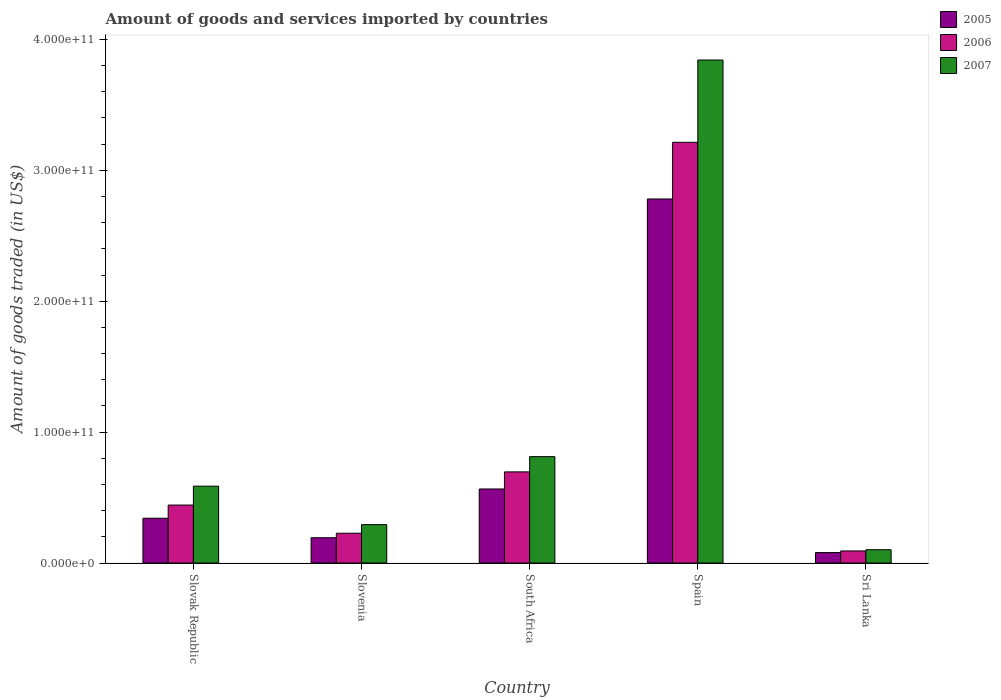Are the number of bars on each tick of the X-axis equal?
Offer a very short reply. Yes. How many bars are there on the 5th tick from the left?
Your answer should be compact. 3. What is the label of the 3rd group of bars from the left?
Your response must be concise. South Africa. What is the total amount of goods and services imported in 2007 in South Africa?
Provide a short and direct response. 8.13e+1. Across all countries, what is the maximum total amount of goods and services imported in 2006?
Your answer should be very brief. 3.21e+11. Across all countries, what is the minimum total amount of goods and services imported in 2007?
Keep it short and to the point. 1.02e+1. In which country was the total amount of goods and services imported in 2005 minimum?
Provide a succinct answer. Sri Lanka. What is the total total amount of goods and services imported in 2005 in the graph?
Provide a short and direct response. 3.96e+11. What is the difference between the total amount of goods and services imported in 2007 in Slovenia and that in Sri Lanka?
Provide a short and direct response. 1.92e+1. What is the difference between the total amount of goods and services imported in 2005 in Sri Lanka and the total amount of goods and services imported in 2006 in Slovak Republic?
Keep it short and to the point. -3.63e+1. What is the average total amount of goods and services imported in 2006 per country?
Keep it short and to the point. 9.35e+1. What is the difference between the total amount of goods and services imported of/in 2007 and total amount of goods and services imported of/in 2006 in Sri Lanka?
Your answer should be compact. 9.39e+08. What is the ratio of the total amount of goods and services imported in 2006 in Slovak Republic to that in South Africa?
Your response must be concise. 0.64. Is the total amount of goods and services imported in 2006 in Slovenia less than that in South Africa?
Your response must be concise. Yes. Is the difference between the total amount of goods and services imported in 2007 in Slovak Republic and Spain greater than the difference between the total amount of goods and services imported in 2006 in Slovak Republic and Spain?
Your response must be concise. No. What is the difference between the highest and the second highest total amount of goods and services imported in 2006?
Ensure brevity in your answer.  2.77e+11. What is the difference between the highest and the lowest total amount of goods and services imported in 2007?
Your response must be concise. 3.74e+11. Is the sum of the total amount of goods and services imported in 2005 in Slovenia and Sri Lanka greater than the maximum total amount of goods and services imported in 2006 across all countries?
Your answer should be very brief. No. What does the 1st bar from the right in Spain represents?
Keep it short and to the point. 2007. Is it the case that in every country, the sum of the total amount of goods and services imported in 2006 and total amount of goods and services imported in 2007 is greater than the total amount of goods and services imported in 2005?
Provide a short and direct response. Yes. How many countries are there in the graph?
Your answer should be compact. 5. What is the difference between two consecutive major ticks on the Y-axis?
Provide a succinct answer. 1.00e+11. Does the graph contain any zero values?
Ensure brevity in your answer.  No. Does the graph contain grids?
Provide a succinct answer. No. How many legend labels are there?
Provide a succinct answer. 3. How are the legend labels stacked?
Provide a short and direct response. Vertical. What is the title of the graph?
Make the answer very short. Amount of goods and services imported by countries. What is the label or title of the Y-axis?
Your answer should be compact. Amount of goods traded (in US$). What is the Amount of goods traded (in US$) in 2005 in Slovak Republic?
Make the answer very short. 3.42e+1. What is the Amount of goods traded (in US$) in 2006 in Slovak Republic?
Provide a succinct answer. 4.43e+1. What is the Amount of goods traded (in US$) in 2007 in Slovak Republic?
Give a very brief answer. 5.87e+1. What is the Amount of goods traded (in US$) of 2005 in Slovenia?
Ensure brevity in your answer.  1.93e+1. What is the Amount of goods traded (in US$) in 2006 in Slovenia?
Your response must be concise. 2.28e+1. What is the Amount of goods traded (in US$) of 2007 in Slovenia?
Your answer should be very brief. 2.93e+1. What is the Amount of goods traded (in US$) of 2005 in South Africa?
Keep it short and to the point. 5.66e+1. What is the Amount of goods traded (in US$) of 2006 in South Africa?
Your answer should be compact. 6.96e+1. What is the Amount of goods traded (in US$) of 2007 in South Africa?
Ensure brevity in your answer.  8.13e+1. What is the Amount of goods traded (in US$) in 2005 in Spain?
Provide a succinct answer. 2.78e+11. What is the Amount of goods traded (in US$) of 2006 in Spain?
Ensure brevity in your answer.  3.21e+11. What is the Amount of goods traded (in US$) in 2007 in Spain?
Offer a terse response. 3.84e+11. What is the Amount of goods traded (in US$) of 2005 in Sri Lanka?
Give a very brief answer. 7.98e+09. What is the Amount of goods traded (in US$) of 2006 in Sri Lanka?
Make the answer very short. 9.23e+09. What is the Amount of goods traded (in US$) of 2007 in Sri Lanka?
Offer a very short reply. 1.02e+1. Across all countries, what is the maximum Amount of goods traded (in US$) in 2005?
Your response must be concise. 2.78e+11. Across all countries, what is the maximum Amount of goods traded (in US$) in 2006?
Keep it short and to the point. 3.21e+11. Across all countries, what is the maximum Amount of goods traded (in US$) of 2007?
Keep it short and to the point. 3.84e+11. Across all countries, what is the minimum Amount of goods traded (in US$) of 2005?
Provide a succinct answer. 7.98e+09. Across all countries, what is the minimum Amount of goods traded (in US$) in 2006?
Your answer should be compact. 9.23e+09. Across all countries, what is the minimum Amount of goods traded (in US$) in 2007?
Your answer should be compact. 1.02e+1. What is the total Amount of goods traded (in US$) in 2005 in the graph?
Your answer should be very brief. 3.96e+11. What is the total Amount of goods traded (in US$) in 2006 in the graph?
Give a very brief answer. 4.67e+11. What is the total Amount of goods traded (in US$) of 2007 in the graph?
Keep it short and to the point. 5.64e+11. What is the difference between the Amount of goods traded (in US$) of 2005 in Slovak Republic and that in Slovenia?
Make the answer very short. 1.49e+1. What is the difference between the Amount of goods traded (in US$) in 2006 in Slovak Republic and that in Slovenia?
Keep it short and to the point. 2.15e+1. What is the difference between the Amount of goods traded (in US$) of 2007 in Slovak Republic and that in Slovenia?
Your answer should be very brief. 2.94e+1. What is the difference between the Amount of goods traded (in US$) in 2005 in Slovak Republic and that in South Africa?
Provide a succinct answer. -2.24e+1. What is the difference between the Amount of goods traded (in US$) in 2006 in Slovak Republic and that in South Africa?
Offer a terse response. -2.53e+1. What is the difference between the Amount of goods traded (in US$) in 2007 in Slovak Republic and that in South Africa?
Your answer should be compact. -2.25e+1. What is the difference between the Amount of goods traded (in US$) in 2005 in Slovak Republic and that in Spain?
Offer a very short reply. -2.44e+11. What is the difference between the Amount of goods traded (in US$) of 2006 in Slovak Republic and that in Spain?
Your answer should be very brief. -2.77e+11. What is the difference between the Amount of goods traded (in US$) in 2007 in Slovak Republic and that in Spain?
Offer a very short reply. -3.26e+11. What is the difference between the Amount of goods traded (in US$) of 2005 in Slovak Republic and that in Sri Lanka?
Provide a succinct answer. 2.62e+1. What is the difference between the Amount of goods traded (in US$) of 2006 in Slovak Republic and that in Sri Lanka?
Give a very brief answer. 3.51e+1. What is the difference between the Amount of goods traded (in US$) of 2007 in Slovak Republic and that in Sri Lanka?
Provide a succinct answer. 4.85e+1. What is the difference between the Amount of goods traded (in US$) in 2005 in Slovenia and that in South Africa?
Make the answer very short. -3.72e+1. What is the difference between the Amount of goods traded (in US$) in 2006 in Slovenia and that in South Africa?
Provide a short and direct response. -4.69e+1. What is the difference between the Amount of goods traded (in US$) of 2007 in Slovenia and that in South Africa?
Offer a very short reply. -5.19e+1. What is the difference between the Amount of goods traded (in US$) in 2005 in Slovenia and that in Spain?
Offer a very short reply. -2.59e+11. What is the difference between the Amount of goods traded (in US$) in 2006 in Slovenia and that in Spain?
Your answer should be compact. -2.99e+11. What is the difference between the Amount of goods traded (in US$) of 2007 in Slovenia and that in Spain?
Provide a short and direct response. -3.55e+11. What is the difference between the Amount of goods traded (in US$) in 2005 in Slovenia and that in Sri Lanka?
Offer a terse response. 1.13e+1. What is the difference between the Amount of goods traded (in US$) of 2006 in Slovenia and that in Sri Lanka?
Give a very brief answer. 1.35e+1. What is the difference between the Amount of goods traded (in US$) of 2007 in Slovenia and that in Sri Lanka?
Ensure brevity in your answer.  1.92e+1. What is the difference between the Amount of goods traded (in US$) of 2005 in South Africa and that in Spain?
Provide a succinct answer. -2.22e+11. What is the difference between the Amount of goods traded (in US$) in 2006 in South Africa and that in Spain?
Offer a very short reply. -2.52e+11. What is the difference between the Amount of goods traded (in US$) in 2007 in South Africa and that in Spain?
Give a very brief answer. -3.03e+11. What is the difference between the Amount of goods traded (in US$) of 2005 in South Africa and that in Sri Lanka?
Offer a very short reply. 4.86e+1. What is the difference between the Amount of goods traded (in US$) in 2006 in South Africa and that in Sri Lanka?
Give a very brief answer. 6.04e+1. What is the difference between the Amount of goods traded (in US$) in 2007 in South Africa and that in Sri Lanka?
Keep it short and to the point. 7.11e+1. What is the difference between the Amount of goods traded (in US$) in 2005 in Spain and that in Sri Lanka?
Your answer should be compact. 2.70e+11. What is the difference between the Amount of goods traded (in US$) of 2006 in Spain and that in Sri Lanka?
Provide a succinct answer. 3.12e+11. What is the difference between the Amount of goods traded (in US$) of 2007 in Spain and that in Sri Lanka?
Make the answer very short. 3.74e+11. What is the difference between the Amount of goods traded (in US$) of 2005 in Slovak Republic and the Amount of goods traded (in US$) of 2006 in Slovenia?
Your answer should be very brief. 1.14e+1. What is the difference between the Amount of goods traded (in US$) of 2005 in Slovak Republic and the Amount of goods traded (in US$) of 2007 in Slovenia?
Your answer should be very brief. 4.88e+09. What is the difference between the Amount of goods traded (in US$) of 2006 in Slovak Republic and the Amount of goods traded (in US$) of 2007 in Slovenia?
Ensure brevity in your answer.  1.50e+1. What is the difference between the Amount of goods traded (in US$) in 2005 in Slovak Republic and the Amount of goods traded (in US$) in 2006 in South Africa?
Ensure brevity in your answer.  -3.54e+1. What is the difference between the Amount of goods traded (in US$) in 2005 in Slovak Republic and the Amount of goods traded (in US$) in 2007 in South Africa?
Your answer should be very brief. -4.70e+1. What is the difference between the Amount of goods traded (in US$) of 2006 in Slovak Republic and the Amount of goods traded (in US$) of 2007 in South Africa?
Your answer should be compact. -3.70e+1. What is the difference between the Amount of goods traded (in US$) in 2005 in Slovak Republic and the Amount of goods traded (in US$) in 2006 in Spain?
Keep it short and to the point. -2.87e+11. What is the difference between the Amount of goods traded (in US$) of 2005 in Slovak Republic and the Amount of goods traded (in US$) of 2007 in Spain?
Ensure brevity in your answer.  -3.50e+11. What is the difference between the Amount of goods traded (in US$) in 2006 in Slovak Republic and the Amount of goods traded (in US$) in 2007 in Spain?
Provide a succinct answer. -3.40e+11. What is the difference between the Amount of goods traded (in US$) of 2005 in Slovak Republic and the Amount of goods traded (in US$) of 2006 in Sri Lanka?
Provide a short and direct response. 2.50e+1. What is the difference between the Amount of goods traded (in US$) in 2005 in Slovak Republic and the Amount of goods traded (in US$) in 2007 in Sri Lanka?
Ensure brevity in your answer.  2.40e+1. What is the difference between the Amount of goods traded (in US$) of 2006 in Slovak Republic and the Amount of goods traded (in US$) of 2007 in Sri Lanka?
Provide a short and direct response. 3.41e+1. What is the difference between the Amount of goods traded (in US$) of 2005 in Slovenia and the Amount of goods traded (in US$) of 2006 in South Africa?
Provide a succinct answer. -5.03e+1. What is the difference between the Amount of goods traded (in US$) in 2005 in Slovenia and the Amount of goods traded (in US$) in 2007 in South Africa?
Offer a terse response. -6.19e+1. What is the difference between the Amount of goods traded (in US$) of 2006 in Slovenia and the Amount of goods traded (in US$) of 2007 in South Africa?
Give a very brief answer. -5.85e+1. What is the difference between the Amount of goods traded (in US$) of 2005 in Slovenia and the Amount of goods traded (in US$) of 2006 in Spain?
Your response must be concise. -3.02e+11. What is the difference between the Amount of goods traded (in US$) of 2005 in Slovenia and the Amount of goods traded (in US$) of 2007 in Spain?
Give a very brief answer. -3.65e+11. What is the difference between the Amount of goods traded (in US$) in 2006 in Slovenia and the Amount of goods traded (in US$) in 2007 in Spain?
Offer a terse response. -3.61e+11. What is the difference between the Amount of goods traded (in US$) of 2005 in Slovenia and the Amount of goods traded (in US$) of 2006 in Sri Lanka?
Your response must be concise. 1.01e+1. What is the difference between the Amount of goods traded (in US$) in 2005 in Slovenia and the Amount of goods traded (in US$) in 2007 in Sri Lanka?
Give a very brief answer. 9.16e+09. What is the difference between the Amount of goods traded (in US$) in 2006 in Slovenia and the Amount of goods traded (in US$) in 2007 in Sri Lanka?
Your answer should be very brief. 1.26e+1. What is the difference between the Amount of goods traded (in US$) in 2005 in South Africa and the Amount of goods traded (in US$) in 2006 in Spain?
Your answer should be very brief. -2.65e+11. What is the difference between the Amount of goods traded (in US$) of 2005 in South Africa and the Amount of goods traded (in US$) of 2007 in Spain?
Offer a very short reply. -3.28e+11. What is the difference between the Amount of goods traded (in US$) of 2006 in South Africa and the Amount of goods traded (in US$) of 2007 in Spain?
Your response must be concise. -3.15e+11. What is the difference between the Amount of goods traded (in US$) in 2005 in South Africa and the Amount of goods traded (in US$) in 2006 in Sri Lanka?
Provide a succinct answer. 4.73e+1. What is the difference between the Amount of goods traded (in US$) in 2005 in South Africa and the Amount of goods traded (in US$) in 2007 in Sri Lanka?
Provide a succinct answer. 4.64e+1. What is the difference between the Amount of goods traded (in US$) in 2006 in South Africa and the Amount of goods traded (in US$) in 2007 in Sri Lanka?
Your answer should be compact. 5.95e+1. What is the difference between the Amount of goods traded (in US$) in 2005 in Spain and the Amount of goods traded (in US$) in 2006 in Sri Lanka?
Ensure brevity in your answer.  2.69e+11. What is the difference between the Amount of goods traded (in US$) of 2005 in Spain and the Amount of goods traded (in US$) of 2007 in Sri Lanka?
Provide a short and direct response. 2.68e+11. What is the difference between the Amount of goods traded (in US$) of 2006 in Spain and the Amount of goods traded (in US$) of 2007 in Sri Lanka?
Make the answer very short. 3.11e+11. What is the average Amount of goods traded (in US$) in 2005 per country?
Provide a succinct answer. 7.92e+1. What is the average Amount of goods traded (in US$) in 2006 per country?
Your answer should be very brief. 9.35e+1. What is the average Amount of goods traded (in US$) in 2007 per country?
Ensure brevity in your answer.  1.13e+11. What is the difference between the Amount of goods traded (in US$) in 2005 and Amount of goods traded (in US$) in 2006 in Slovak Republic?
Provide a short and direct response. -1.01e+1. What is the difference between the Amount of goods traded (in US$) in 2005 and Amount of goods traded (in US$) in 2007 in Slovak Republic?
Your answer should be compact. -2.45e+1. What is the difference between the Amount of goods traded (in US$) in 2006 and Amount of goods traded (in US$) in 2007 in Slovak Republic?
Your response must be concise. -1.44e+1. What is the difference between the Amount of goods traded (in US$) in 2005 and Amount of goods traded (in US$) in 2006 in Slovenia?
Provide a succinct answer. -3.45e+09. What is the difference between the Amount of goods traded (in US$) of 2005 and Amount of goods traded (in US$) of 2007 in Slovenia?
Give a very brief answer. -1.00e+1. What is the difference between the Amount of goods traded (in US$) of 2006 and Amount of goods traded (in US$) of 2007 in Slovenia?
Provide a short and direct response. -6.56e+09. What is the difference between the Amount of goods traded (in US$) of 2005 and Amount of goods traded (in US$) of 2006 in South Africa?
Offer a very short reply. -1.31e+1. What is the difference between the Amount of goods traded (in US$) of 2005 and Amount of goods traded (in US$) of 2007 in South Africa?
Offer a very short reply. -2.47e+1. What is the difference between the Amount of goods traded (in US$) in 2006 and Amount of goods traded (in US$) in 2007 in South Africa?
Offer a terse response. -1.16e+1. What is the difference between the Amount of goods traded (in US$) in 2005 and Amount of goods traded (in US$) in 2006 in Spain?
Keep it short and to the point. -4.33e+1. What is the difference between the Amount of goods traded (in US$) in 2005 and Amount of goods traded (in US$) in 2007 in Spain?
Your answer should be very brief. -1.06e+11. What is the difference between the Amount of goods traded (in US$) in 2006 and Amount of goods traded (in US$) in 2007 in Spain?
Make the answer very short. -6.29e+1. What is the difference between the Amount of goods traded (in US$) of 2005 and Amount of goods traded (in US$) of 2006 in Sri Lanka?
Ensure brevity in your answer.  -1.25e+09. What is the difference between the Amount of goods traded (in US$) of 2005 and Amount of goods traded (in US$) of 2007 in Sri Lanka?
Offer a very short reply. -2.19e+09. What is the difference between the Amount of goods traded (in US$) in 2006 and Amount of goods traded (in US$) in 2007 in Sri Lanka?
Offer a terse response. -9.39e+08. What is the ratio of the Amount of goods traded (in US$) in 2005 in Slovak Republic to that in Slovenia?
Ensure brevity in your answer.  1.77. What is the ratio of the Amount of goods traded (in US$) of 2006 in Slovak Republic to that in Slovenia?
Your answer should be compact. 1.94. What is the ratio of the Amount of goods traded (in US$) in 2007 in Slovak Republic to that in Slovenia?
Provide a short and direct response. 2. What is the ratio of the Amount of goods traded (in US$) of 2005 in Slovak Republic to that in South Africa?
Provide a short and direct response. 0.6. What is the ratio of the Amount of goods traded (in US$) in 2006 in Slovak Republic to that in South Africa?
Ensure brevity in your answer.  0.64. What is the ratio of the Amount of goods traded (in US$) of 2007 in Slovak Republic to that in South Africa?
Give a very brief answer. 0.72. What is the ratio of the Amount of goods traded (in US$) in 2005 in Slovak Republic to that in Spain?
Offer a very short reply. 0.12. What is the ratio of the Amount of goods traded (in US$) in 2006 in Slovak Republic to that in Spain?
Your answer should be very brief. 0.14. What is the ratio of the Amount of goods traded (in US$) in 2007 in Slovak Republic to that in Spain?
Provide a succinct answer. 0.15. What is the ratio of the Amount of goods traded (in US$) in 2005 in Slovak Republic to that in Sri Lanka?
Your answer should be very brief. 4.29. What is the ratio of the Amount of goods traded (in US$) of 2006 in Slovak Republic to that in Sri Lanka?
Give a very brief answer. 4.8. What is the ratio of the Amount of goods traded (in US$) of 2007 in Slovak Republic to that in Sri Lanka?
Offer a terse response. 5.78. What is the ratio of the Amount of goods traded (in US$) in 2005 in Slovenia to that in South Africa?
Your answer should be very brief. 0.34. What is the ratio of the Amount of goods traded (in US$) in 2006 in Slovenia to that in South Africa?
Make the answer very short. 0.33. What is the ratio of the Amount of goods traded (in US$) in 2007 in Slovenia to that in South Africa?
Give a very brief answer. 0.36. What is the ratio of the Amount of goods traded (in US$) in 2005 in Slovenia to that in Spain?
Your answer should be very brief. 0.07. What is the ratio of the Amount of goods traded (in US$) of 2006 in Slovenia to that in Spain?
Your response must be concise. 0.07. What is the ratio of the Amount of goods traded (in US$) of 2007 in Slovenia to that in Spain?
Make the answer very short. 0.08. What is the ratio of the Amount of goods traded (in US$) of 2005 in Slovenia to that in Sri Lanka?
Make the answer very short. 2.42. What is the ratio of the Amount of goods traded (in US$) of 2006 in Slovenia to that in Sri Lanka?
Your answer should be very brief. 2.47. What is the ratio of the Amount of goods traded (in US$) of 2007 in Slovenia to that in Sri Lanka?
Your answer should be compact. 2.88. What is the ratio of the Amount of goods traded (in US$) in 2005 in South Africa to that in Spain?
Give a very brief answer. 0.2. What is the ratio of the Amount of goods traded (in US$) of 2006 in South Africa to that in Spain?
Your answer should be very brief. 0.22. What is the ratio of the Amount of goods traded (in US$) of 2007 in South Africa to that in Spain?
Offer a terse response. 0.21. What is the ratio of the Amount of goods traded (in US$) in 2005 in South Africa to that in Sri Lanka?
Your answer should be compact. 7.09. What is the ratio of the Amount of goods traded (in US$) in 2006 in South Africa to that in Sri Lanka?
Your answer should be compact. 7.55. What is the ratio of the Amount of goods traded (in US$) in 2007 in South Africa to that in Sri Lanka?
Provide a succinct answer. 7.99. What is the ratio of the Amount of goods traded (in US$) in 2005 in Spain to that in Sri Lanka?
Your answer should be very brief. 34.86. What is the ratio of the Amount of goods traded (in US$) in 2006 in Spain to that in Sri Lanka?
Provide a succinct answer. 34.83. What is the ratio of the Amount of goods traded (in US$) of 2007 in Spain to that in Sri Lanka?
Your response must be concise. 37.79. What is the difference between the highest and the second highest Amount of goods traded (in US$) in 2005?
Your answer should be compact. 2.22e+11. What is the difference between the highest and the second highest Amount of goods traded (in US$) of 2006?
Keep it short and to the point. 2.52e+11. What is the difference between the highest and the second highest Amount of goods traded (in US$) of 2007?
Offer a very short reply. 3.03e+11. What is the difference between the highest and the lowest Amount of goods traded (in US$) of 2005?
Ensure brevity in your answer.  2.70e+11. What is the difference between the highest and the lowest Amount of goods traded (in US$) of 2006?
Provide a succinct answer. 3.12e+11. What is the difference between the highest and the lowest Amount of goods traded (in US$) of 2007?
Provide a succinct answer. 3.74e+11. 